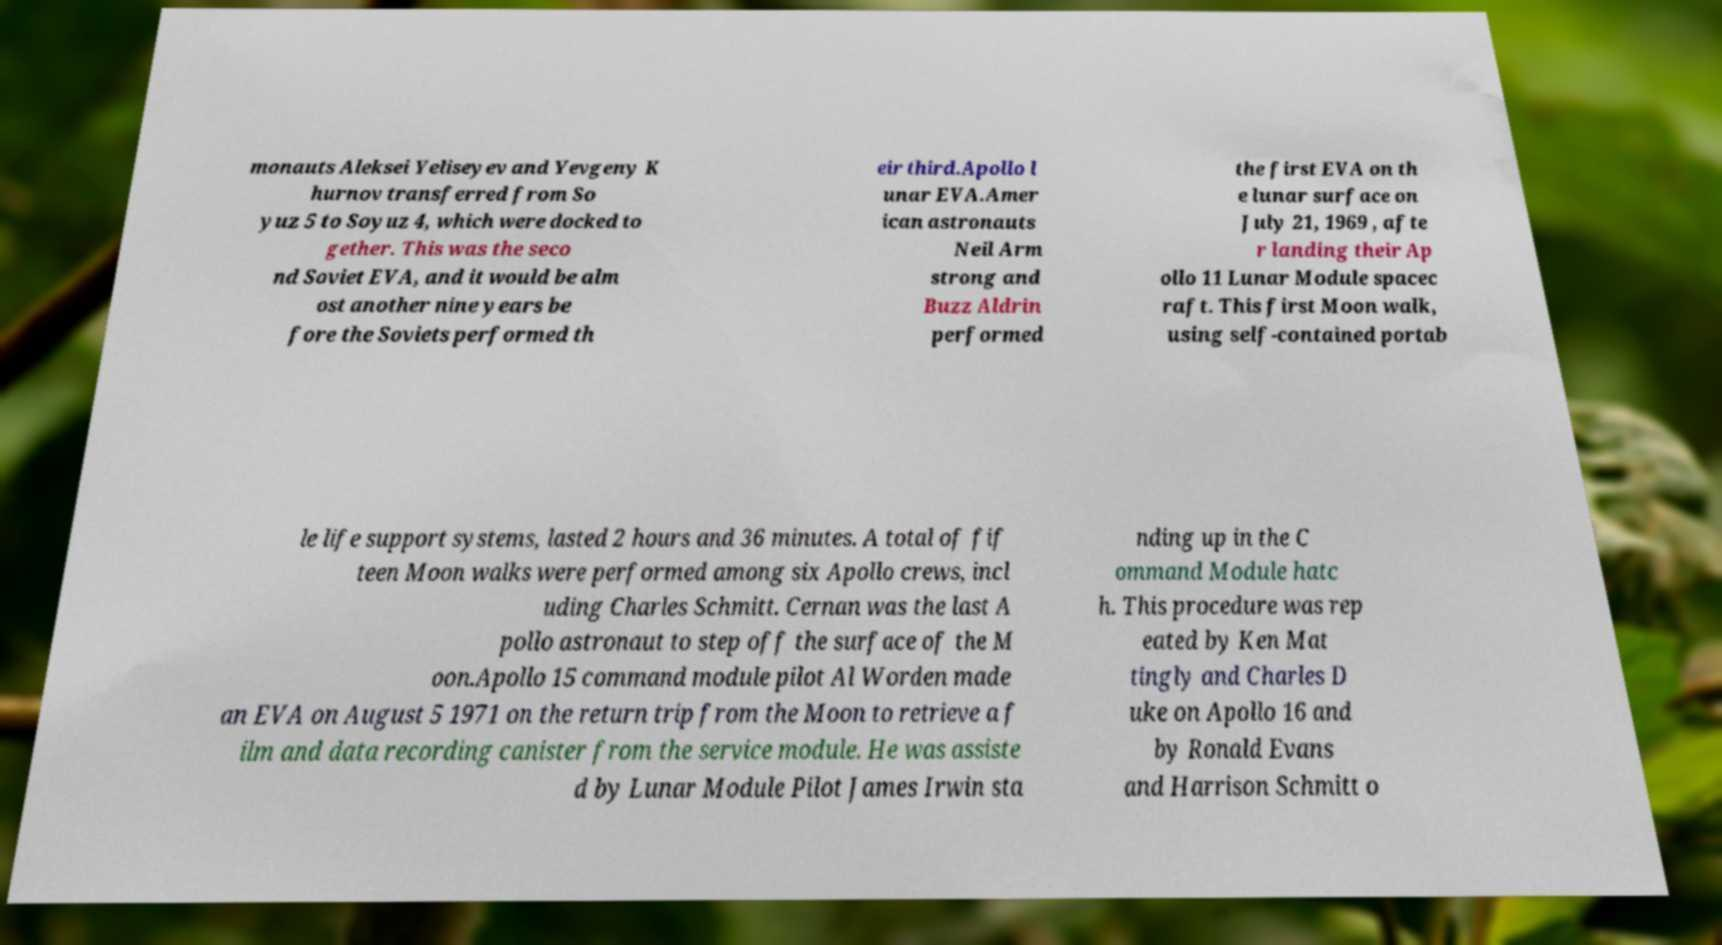For documentation purposes, I need the text within this image transcribed. Could you provide that? monauts Aleksei Yeliseyev and Yevgeny K hurnov transferred from So yuz 5 to Soyuz 4, which were docked to gether. This was the seco nd Soviet EVA, and it would be alm ost another nine years be fore the Soviets performed th eir third.Apollo l unar EVA.Amer ican astronauts Neil Arm strong and Buzz Aldrin performed the first EVA on th e lunar surface on July 21, 1969 , afte r landing their Ap ollo 11 Lunar Module spacec raft. This first Moon walk, using self-contained portab le life support systems, lasted 2 hours and 36 minutes. A total of fif teen Moon walks were performed among six Apollo crews, incl uding Charles Schmitt. Cernan was the last A pollo astronaut to step off the surface of the M oon.Apollo 15 command module pilot Al Worden made an EVA on August 5 1971 on the return trip from the Moon to retrieve a f ilm and data recording canister from the service module. He was assiste d by Lunar Module Pilot James Irwin sta nding up in the C ommand Module hatc h. This procedure was rep eated by Ken Mat tingly and Charles D uke on Apollo 16 and by Ronald Evans and Harrison Schmitt o 